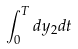Convert formula to latex. <formula><loc_0><loc_0><loc_500><loc_500>\int _ { 0 } ^ { T } d y _ { 2 } d t</formula> 